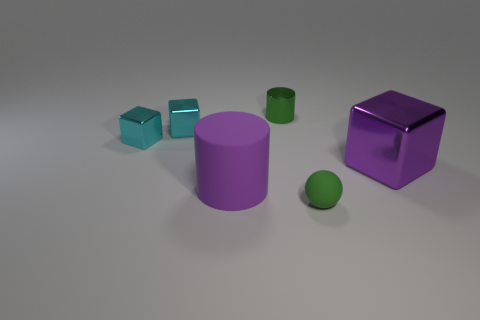Subtract all big purple blocks. How many blocks are left? 2 Add 1 small cylinders. How many objects exist? 7 Subtract all green cylinders. How many cylinders are left? 1 Subtract all purple balls. Subtract all purple cylinders. How many balls are left? 1 Subtract all purple balls. How many green cylinders are left? 1 Subtract all cyan metallic blocks. Subtract all large shiny blocks. How many objects are left? 3 Add 4 tiny green shiny objects. How many tiny green shiny objects are left? 5 Add 1 small gray cubes. How many small gray cubes exist? 1 Subtract 0 gray cylinders. How many objects are left? 6 Subtract all cylinders. How many objects are left? 4 